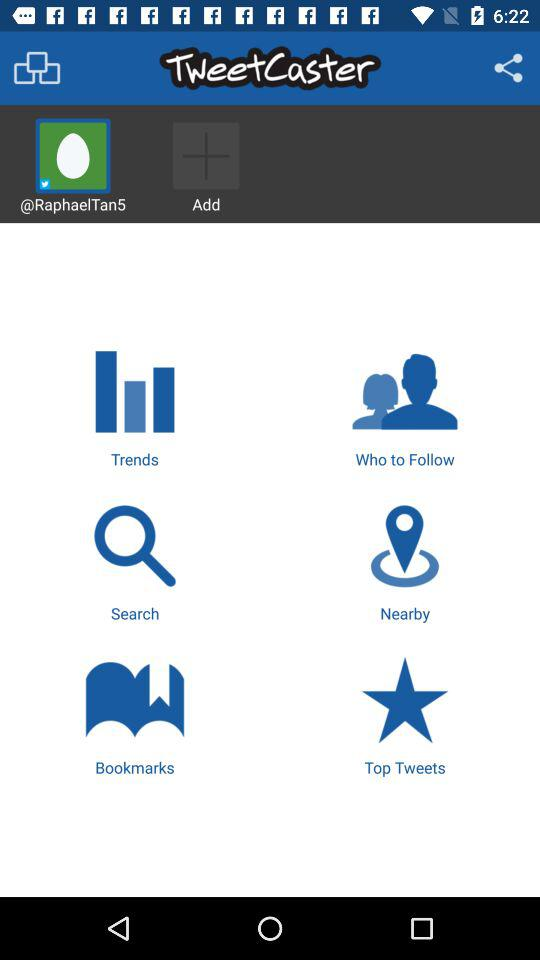What is the username? The username is "@RaphaelTan5". 